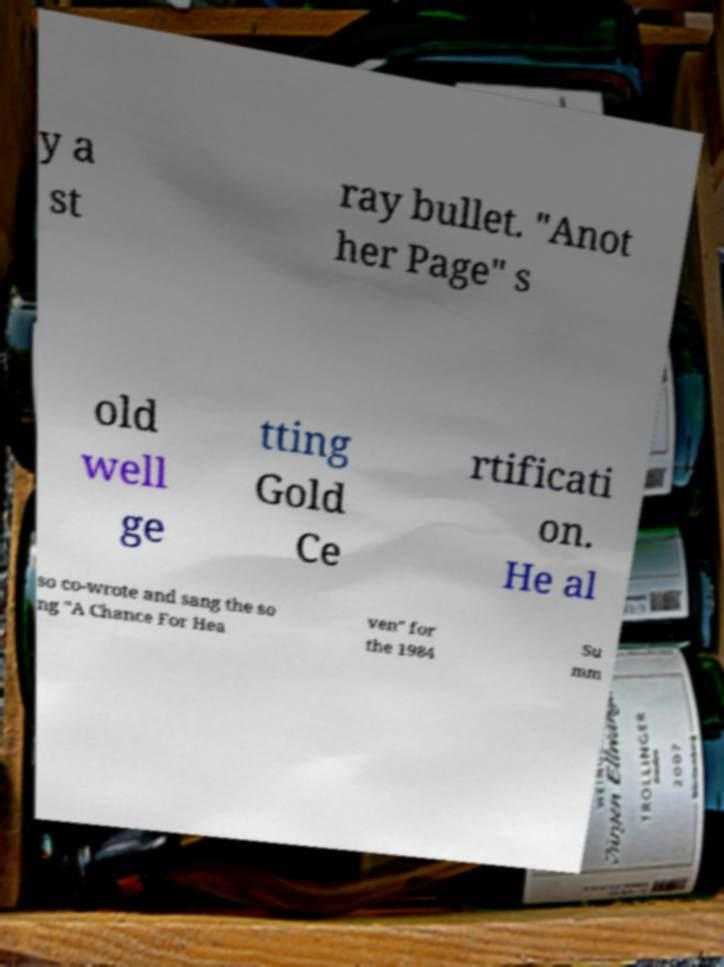Could you assist in decoding the text presented in this image and type it out clearly? y a st ray bullet. "Anot her Page" s old well ge tting Gold Ce rtificati on. He al so co-wrote and sang the so ng "A Chance For Hea ven" for the 1984 Su mm 